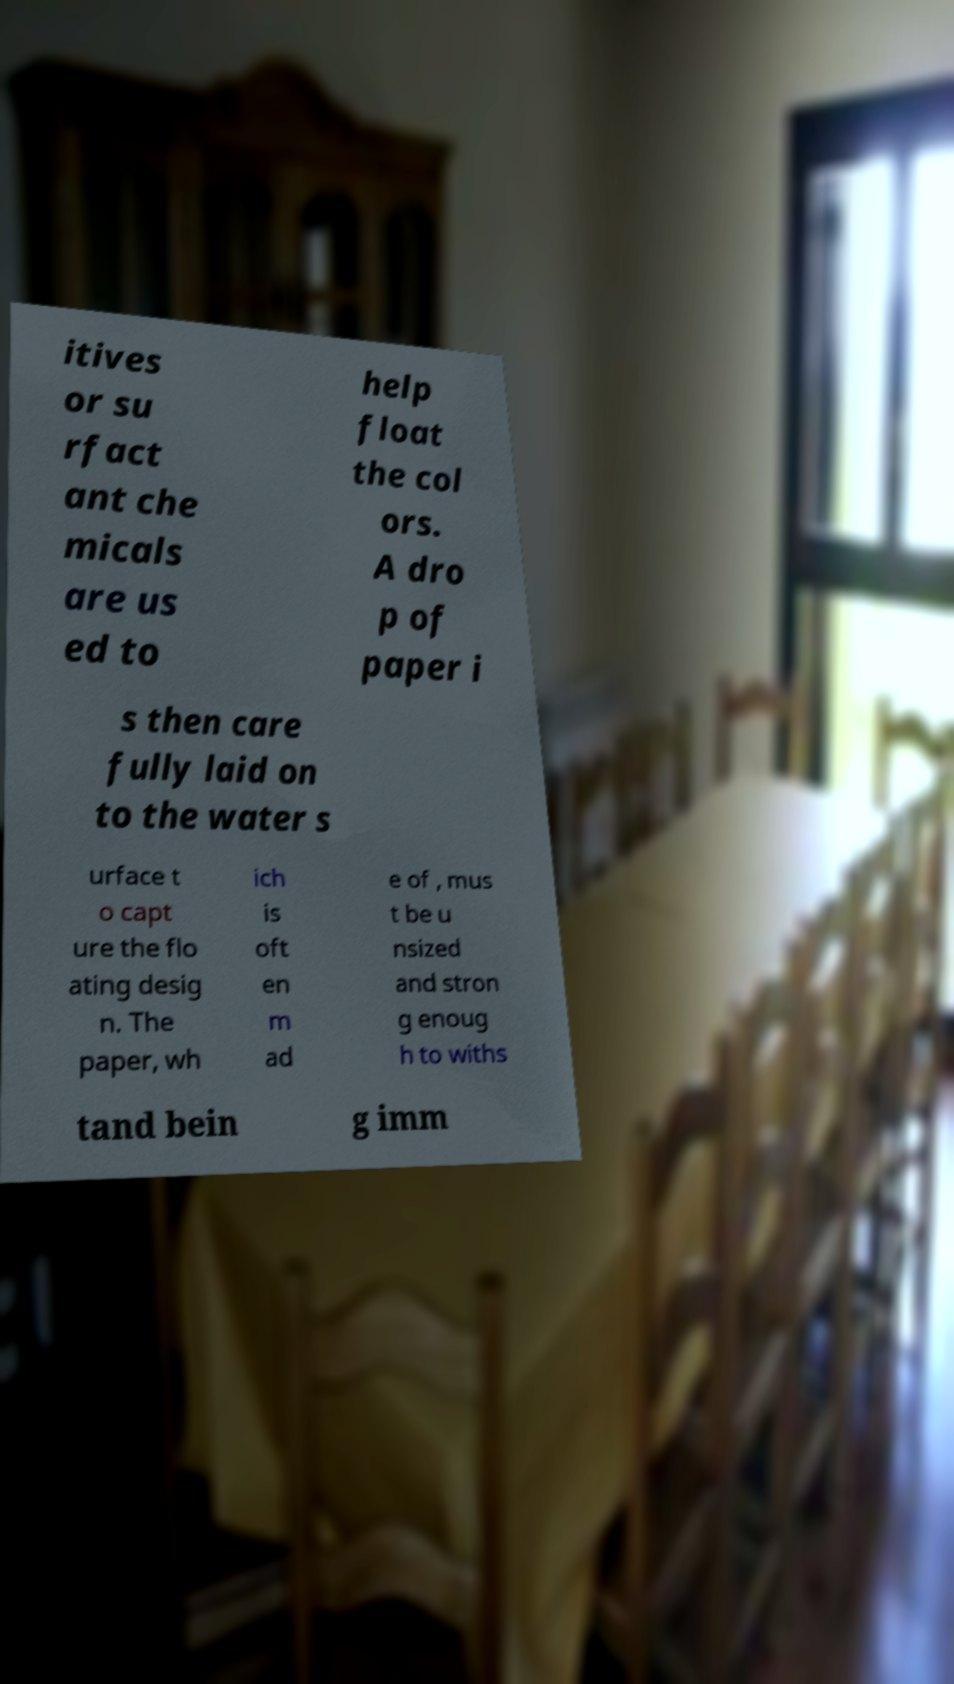Can you accurately transcribe the text from the provided image for me? itives or su rfact ant che micals are us ed to help float the col ors. A dro p of paper i s then care fully laid on to the water s urface t o capt ure the flo ating desig n. The paper, wh ich is oft en m ad e of , mus t be u nsized and stron g enoug h to withs tand bein g imm 